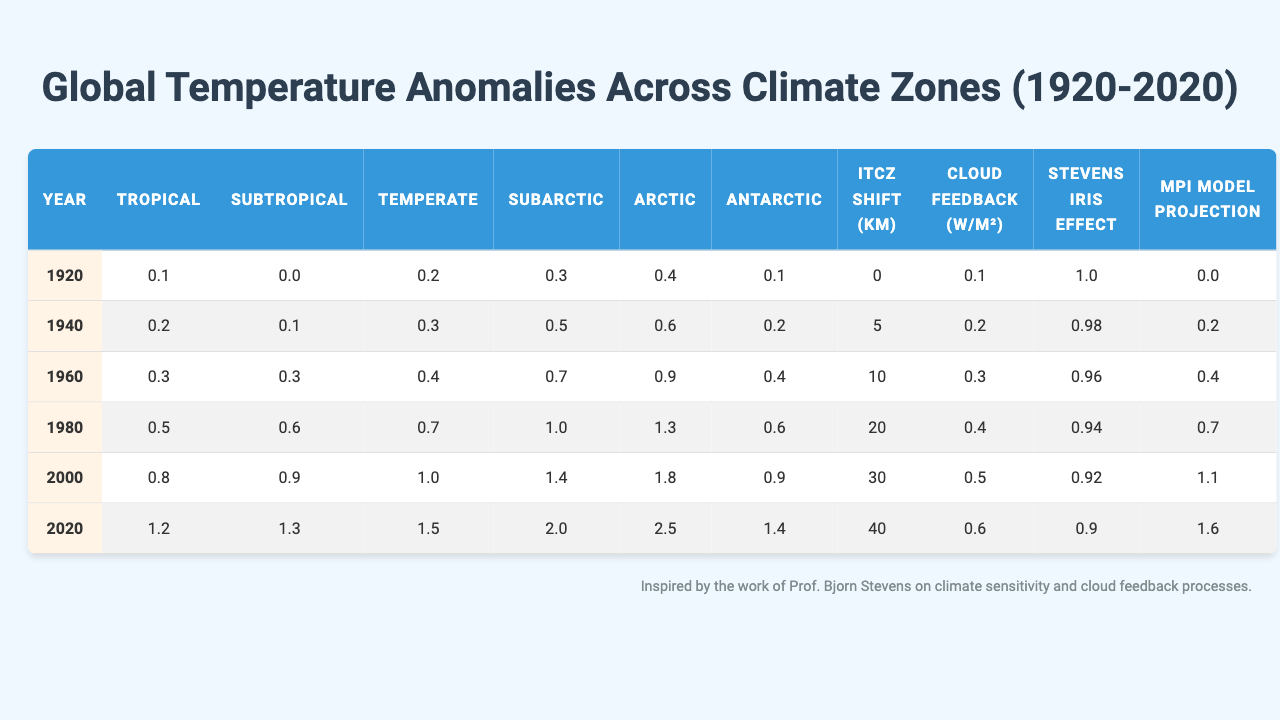What was the Arctic temperature anomaly in 1980? Referring to the table, we locate the row for the year 1980 and find the Arctic temperature anomaly value, which is 1.3.
Answer: 1.3 Which climate zone had the highest temperature anomaly in 2020? In the year 2020, we check the temperature anomalies for all climate zones and find that Arctic with a value of 2.5 is the highest.
Answer: Arctic What was the temperature anomaly difference between the Subarctic and Antarctic in 2000? For the year 2000, Subarctic temperature anomaly is 1.4 and Antarctic is 0.9. The difference is 1.4 - 0.9 = 0.5.
Answer: 0.5 What is the average temperature anomaly for the Temperate zone over the years? The Temperate anomalies are 0.2, 0.3, 0.4, 0.7, 1.0, and 1.5. Their total is 0.2 + 0.3 + 0.4 + 0.7 + 1.0 + 1.5 = 4.1, and dividing by 6 gives an average of approximately 0.683.
Answer: 0.683 Was there a steady increase in Tropical temperature anomalies over the century shown? By examining the values for the Tropical zone across all years (0.1, 0.2, 0.3, 0.5, 0.8, 1.2), we see that each subsequent value is higher than the preceding one, indicating a steady increase.
Answer: Yes How many years had Subtropical temperature anomalies above 1.0? Looking through the Subtropical values (0.0, 0.1, 0.3, 0.6, 0.9, 1.3), we find that only in the year 2020 is the value above 1.0. Thus, there is only 1 year.
Answer: 1 What is the total increase in the Arctic temperature anomaly from 1920 to 2020? The Arctic anomalies for those years are 0.4 (1920) and 2.5 (2020). The total increase is 2.5 - 0.4 = 2.1.
Answer: 2.1 In which year did the MPI Model Projection reach 1.1? Checking the MPI Model Projection values (0.0, 0.2, 0.4, 0.7, 1.1, 1.6), we find that it reached 1.1 in the year 2000.
Answer: 2000 What trend is observed in the Cloud Feedback values over the years? The Cloud Feedback values are 0.1, 0.2, 0.3, 0.4, 0.5, 0.6, which consistently increase over the years.
Answer: Increasing How does the ITCZ Shift distance relate to changes in the Arctic temperature anomaly? The ITCZ Shift values over the years are (0, 5, 10, 20, 30, 40) and correspondingly the Arctic temperature anomalies (0.4, 0.6, 0.9, 1.3, 1.8, 2.5) also increase. This shows a correlation where greater shifts correspond to higher anomalies.
Answer: Correlation exists 